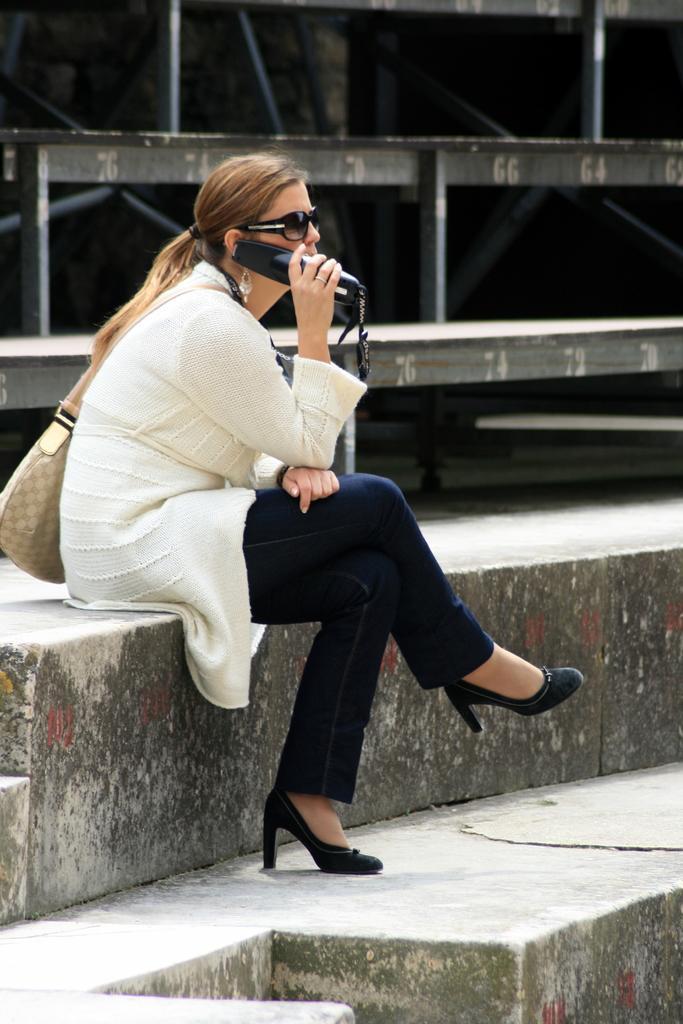Could you give a brief overview of what you see in this image? In this picture there is a woman sitting and holding the device. At the back there are rods and there are numbers on the rods. At the bottom there is a staircase. 